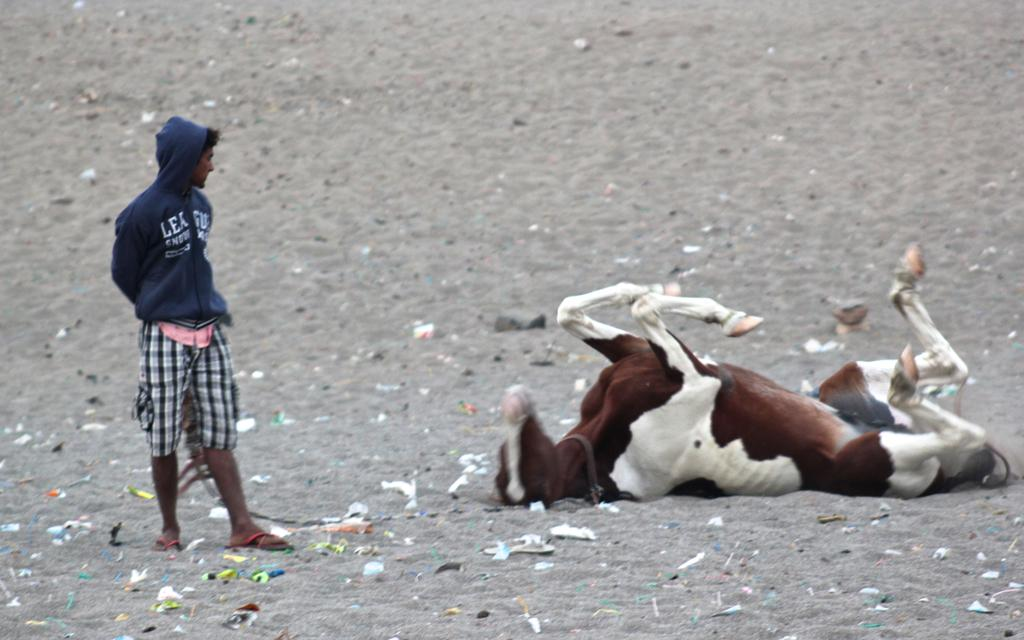What animal is present in the image? There is a horse in the image. Are there any human figures in the image? Yes, there is a person in the image. What type of terrain is visible at the bottom of the image? There is sand at the bottom of the image. How many potatoes can be seen in the image? There are no potatoes present in the image. What type of friends are depicted in the image? There is no reference to friends in the image. 